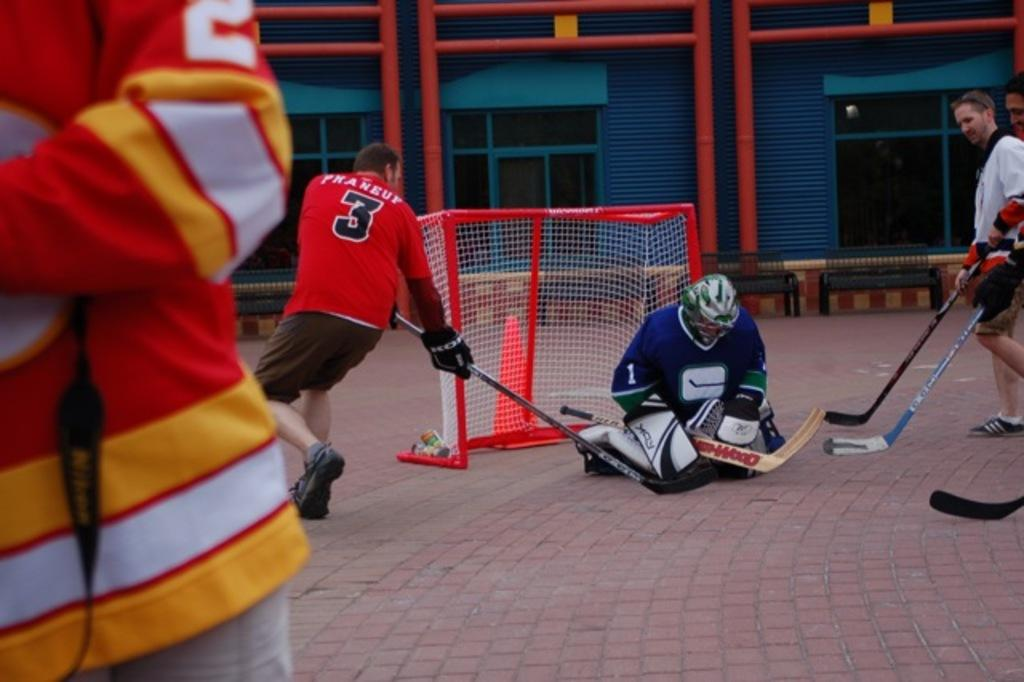<image>
Write a terse but informative summary of the picture. number 3 Phaneup is trying to score a hockey goal 